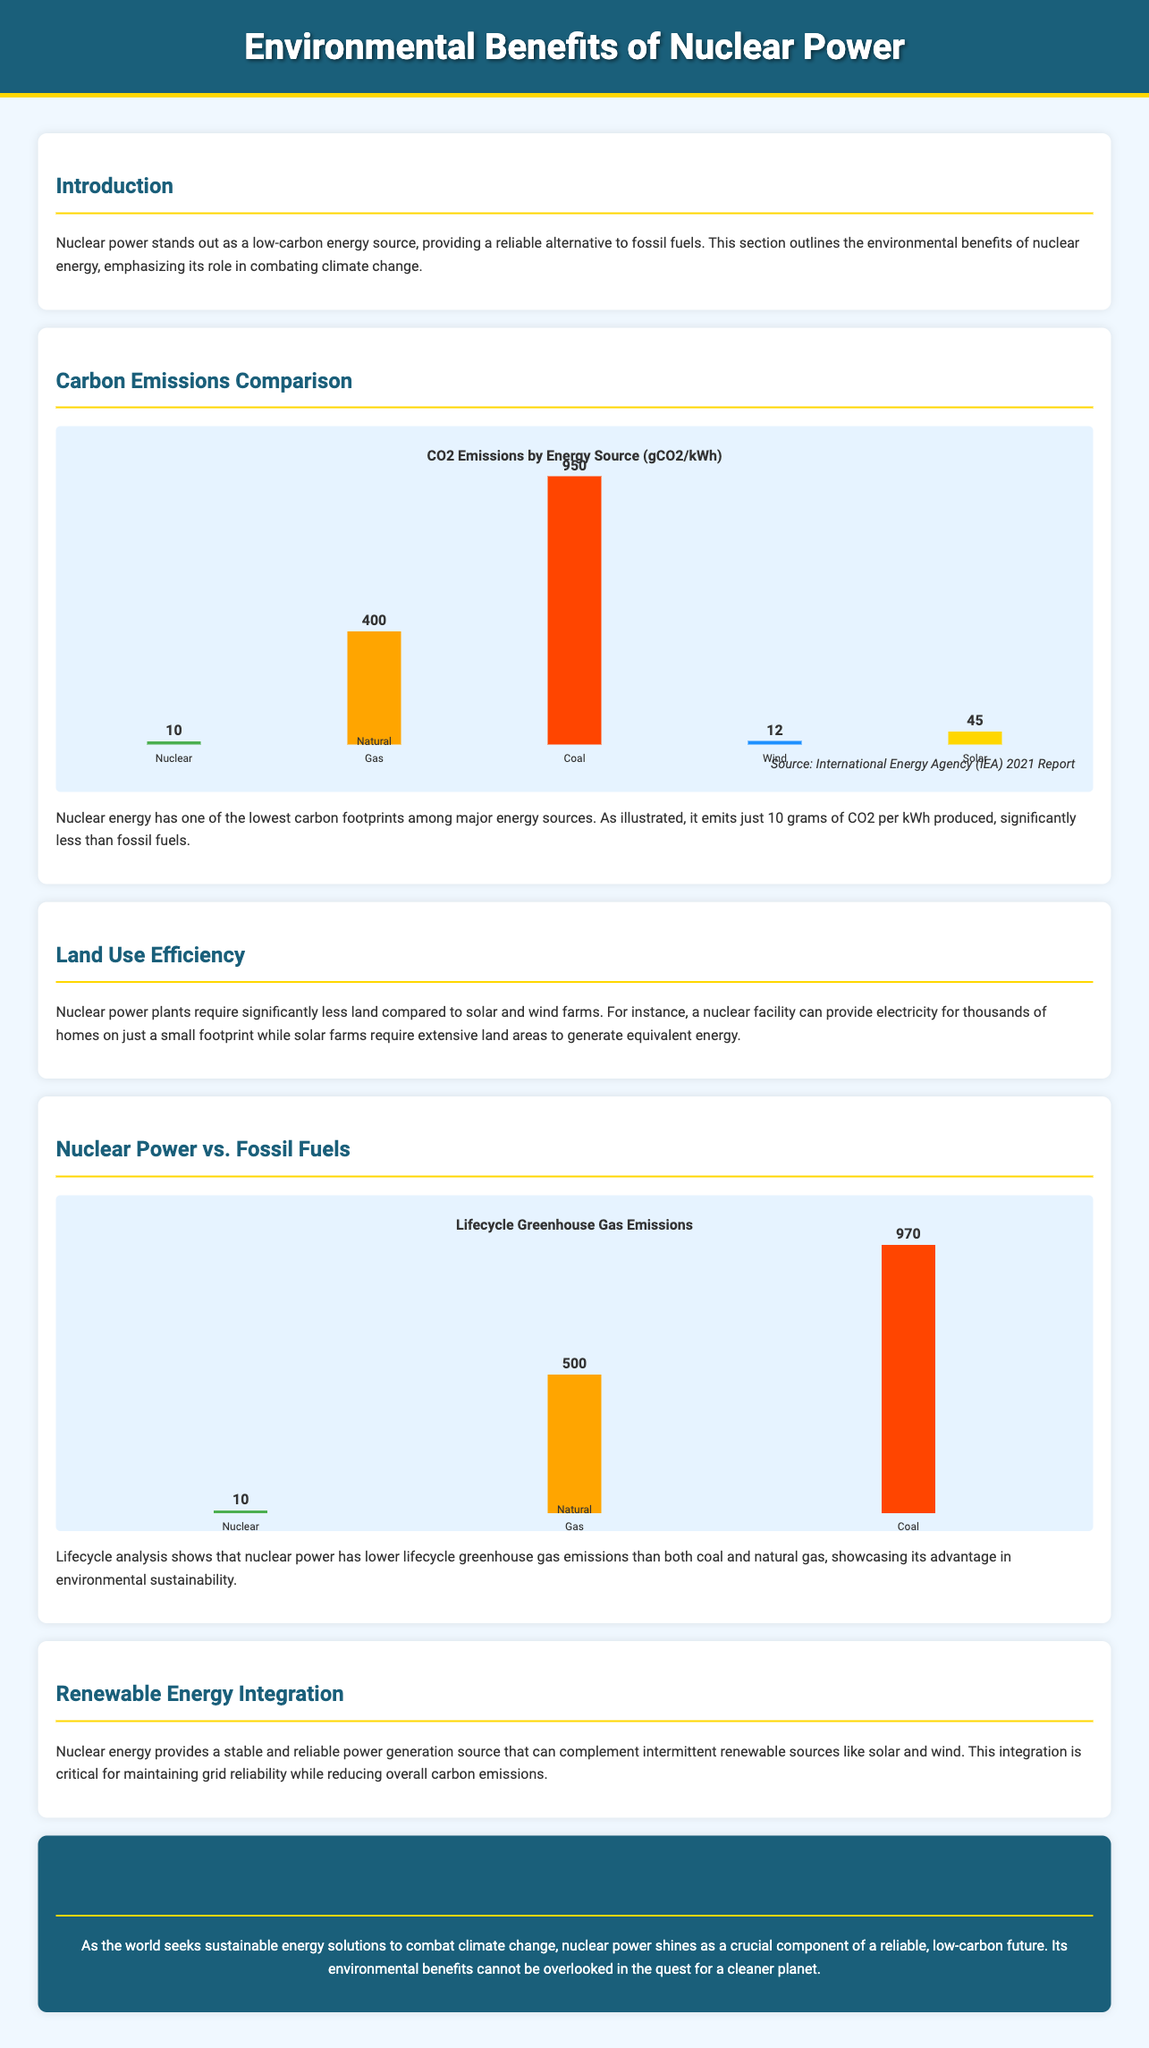What is the CO2 emission per kWh for Nuclear energy? The document states that nuclear energy emits 10 grams of CO2 per kWh produced.
Answer: 10 grams What is the CO2 emission per kWh for Coal? The chart indicates that coal emits 950 grams of CO2 per kWh produced.
Answer: 950 grams How much lower are the lifecycle greenhouse gas emissions of Nuclear compared to Coal? The lifecycle greenhouse gas emissions for nuclear energy are 10 grams, and for coal, they are 970 grams, making it 960 grams lower.
Answer: 960 grams What color represents Natural Gas in the CO2 Emissions by Energy Source chart? The document mentions that Natural Gas is represented by the color orange (#FFA500).
Answer: Orange Which energy source has the highest greenhouse gas emissions? The document indicates that coal has the highest greenhouse gas emissions, as shown in the charts presented.
Answer: Coal How does Nuclear energy compare in land use efficiency according to the document? The text states that Nuclear power plants require significantly less land compared to solar and wind farms.
Answer: Less land What conclusion is drawn about Nuclear power in the conclusion section? The conclusion emphasizes that nuclear power is a crucial component of a reliable, low-carbon future for sustainable energy solutions.
Answer: Crucial component Which two renewable energy sources are mentioned as being intermittent? The document specifies that solar and wind are the intermittent renewable sources mentioned.
Answer: Solar and Wind What is the main environmental benefit emphasized about nuclear energy? The document emphasizes the low carbon footprint of nuclear energy as the main environmental benefit.
Answer: Low carbon footprint 